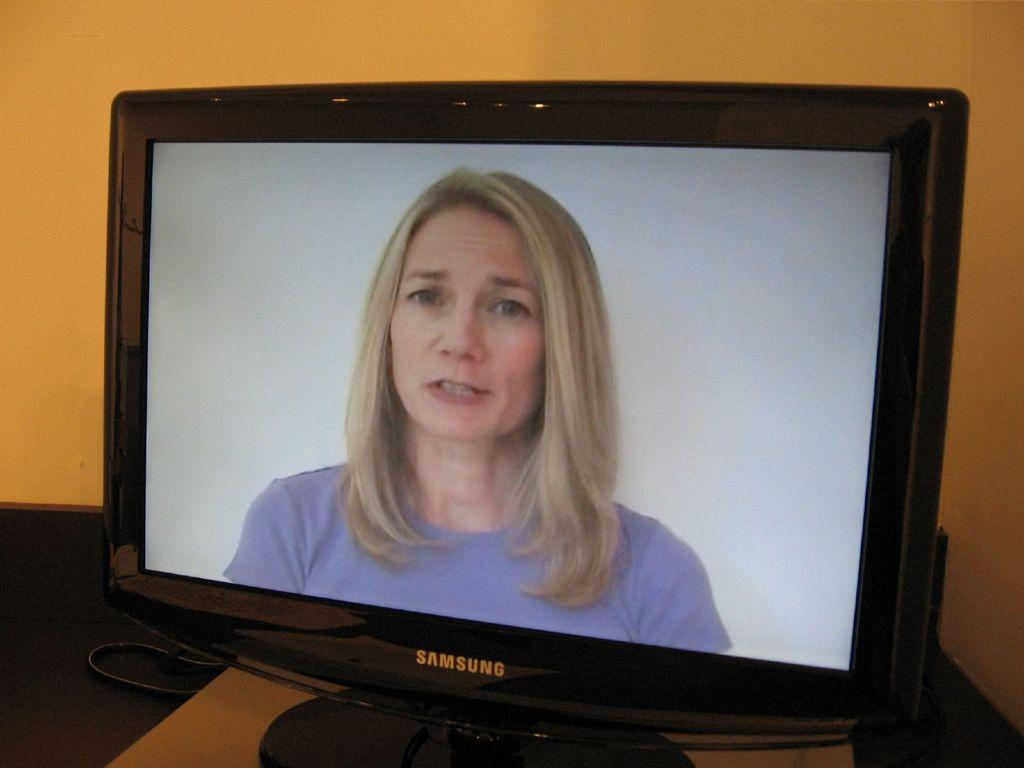<image>
Write a terse but informative summary of the picture. A Samsung monitor displays a blond woman with a serious expression. 